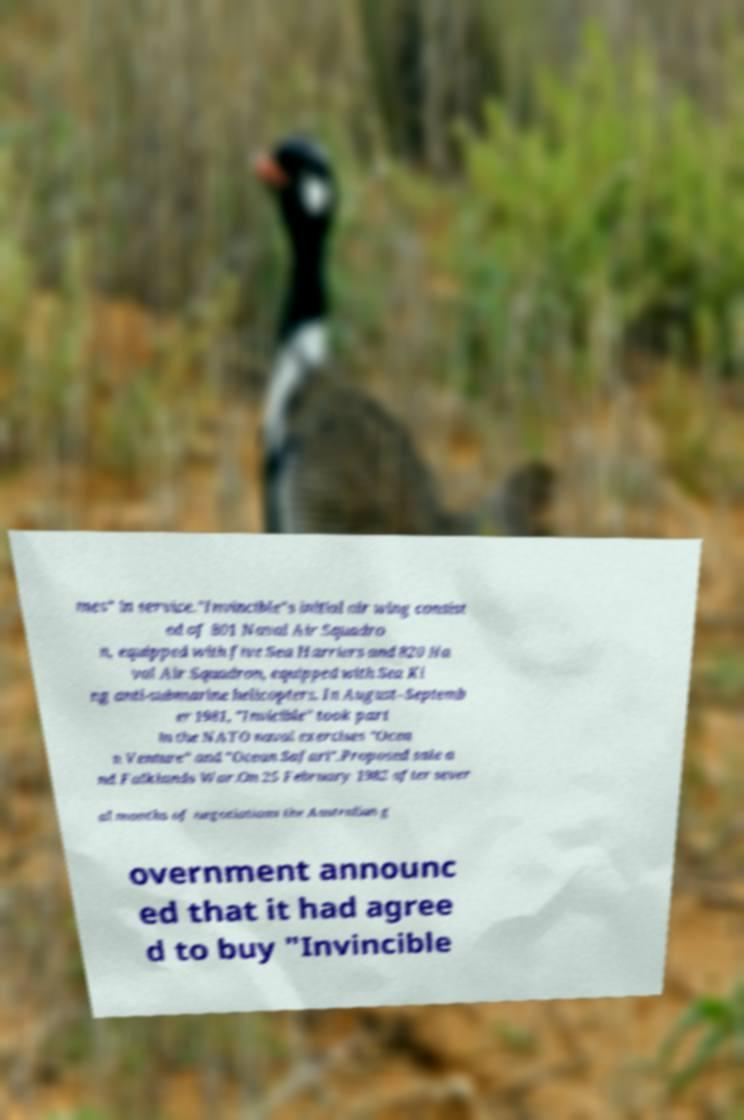What messages or text are displayed in this image? I need them in a readable, typed format. mes" in service."Invincible"s initial air wing consist ed of 801 Naval Air Squadro n, equipped with five Sea Harriers and 820 Na val Air Squadron, equipped with Sea Ki ng anti-submarine helicopters. In August–Septemb er 1981, "Invicible" took part in the NATO naval exercises "Ocea n Venture" and "Ocean Safari".Proposed sale a nd Falklands War.On 25 February 1982 after sever al months of negotiations the Australian g overnment announc ed that it had agree d to buy "Invincible 